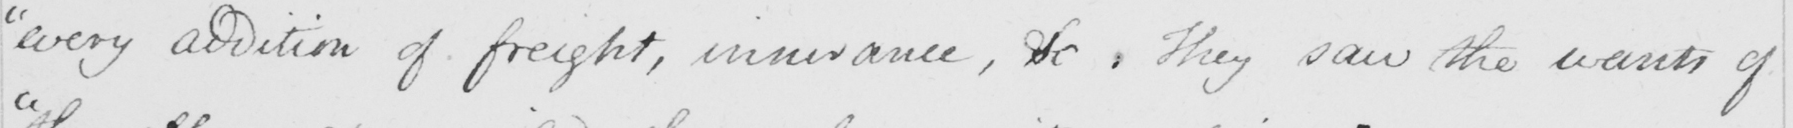Can you read and transcribe this handwriting? " every addition of freight , insurance , &c . They saw the wants of 